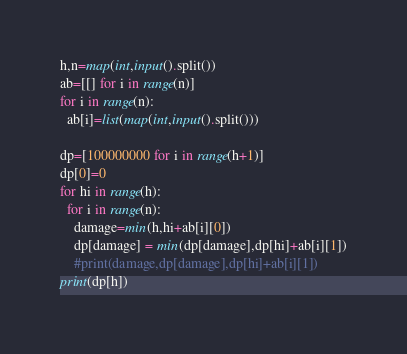Convert code to text. <code><loc_0><loc_0><loc_500><loc_500><_Python_>h,n=map(int,input().split())
ab=[[] for i in range(n)]
for i in range(n):
  ab[i]=list(map(int,input().split()))
  
dp=[100000000 for i in range(h+1)]
dp[0]=0
for hi in range(h):
  for i in range(n):
    damage=min(h,hi+ab[i][0])
    dp[damage] = min(dp[damage],dp[hi]+ab[i][1])
    #print(damage,dp[damage],dp[hi]+ab[i][1])
print(dp[h])</code> 